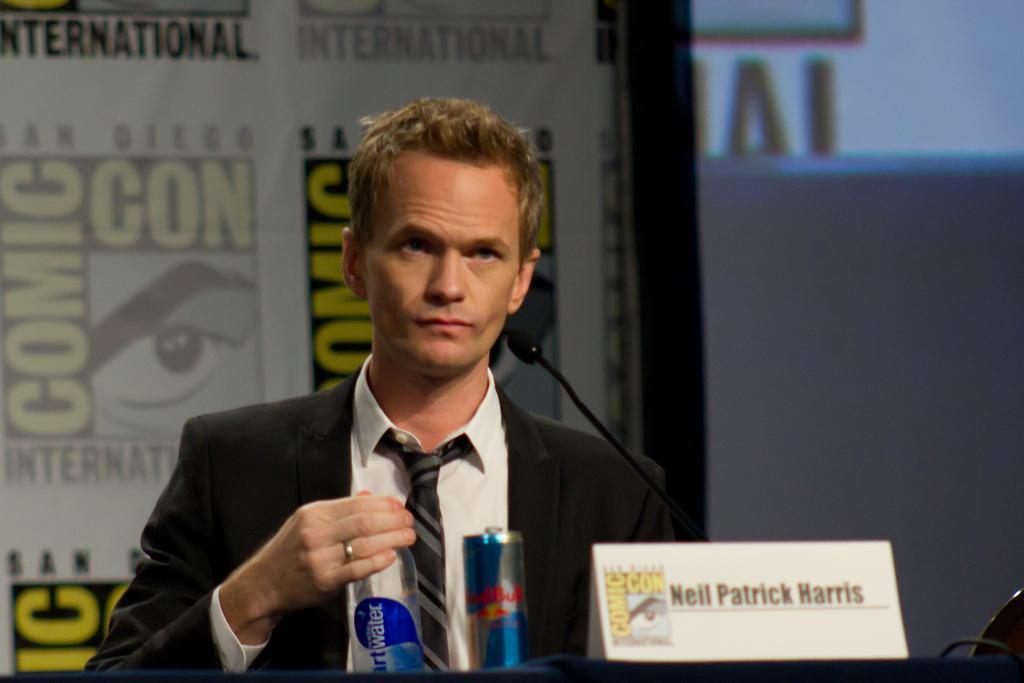Please provide a concise description of this image. In this image I can see a person wearing a suit. There is a bottle, can and a microphone in the front. There is a screen and a banner at the back. 